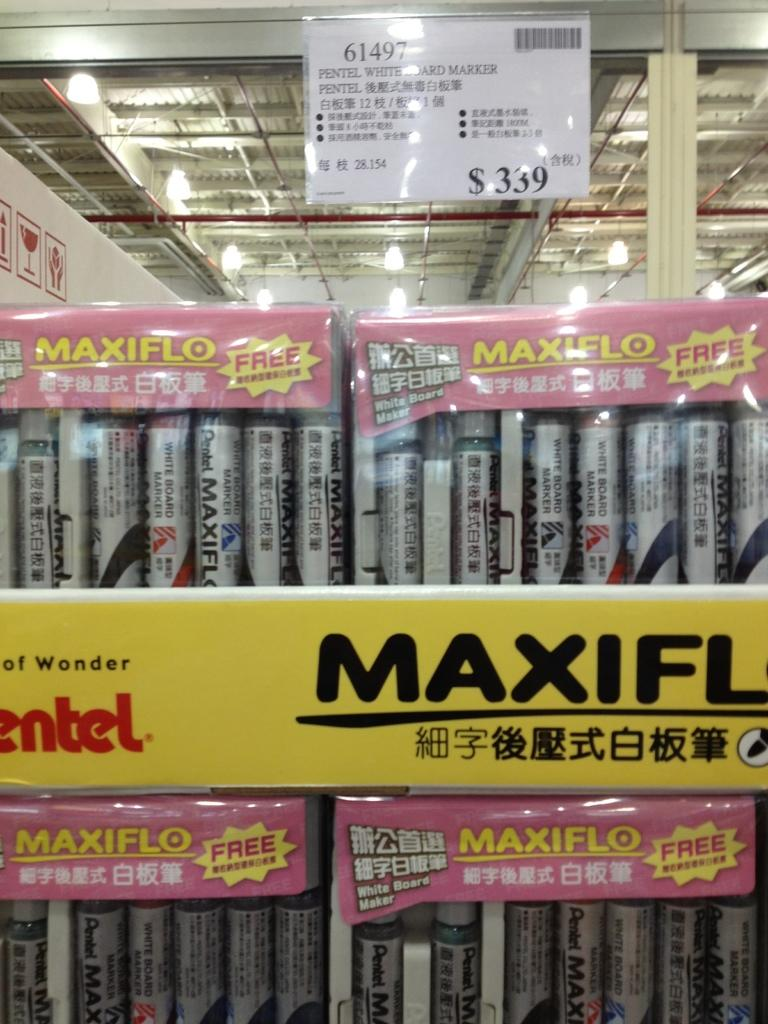<image>
Create a compact narrative representing the image presented. A display of products advertises with the word free. 